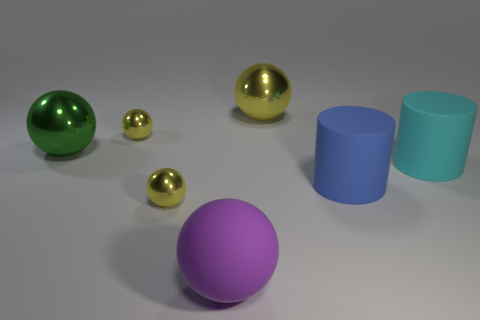Subtract all green balls. How many balls are left? 4 Subtract all cyan cylinders. How many cylinders are left? 1 Add 2 purple objects. How many objects exist? 9 Subtract all cylinders. How many objects are left? 5 Subtract all cyan blocks. How many gray cylinders are left? 0 Subtract all green metallic balls. Subtract all tiny matte objects. How many objects are left? 6 Add 3 big green shiny things. How many big green shiny things are left? 4 Add 3 big blue rubber things. How many big blue rubber things exist? 4 Subtract 0 red cubes. How many objects are left? 7 Subtract all yellow cylinders. Subtract all cyan spheres. How many cylinders are left? 2 